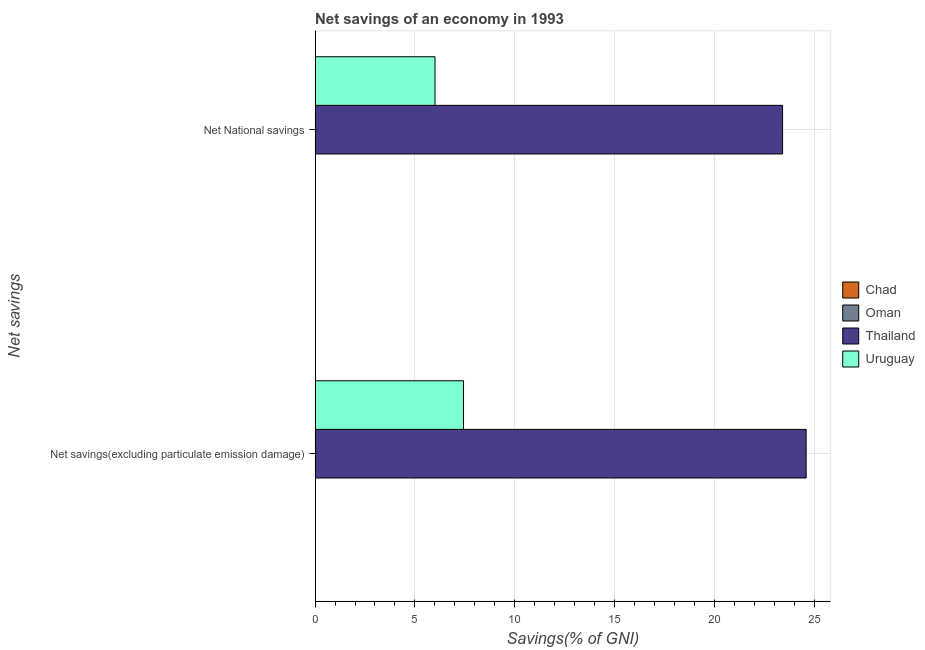How many bars are there on the 2nd tick from the bottom?
Your response must be concise. 2. What is the label of the 1st group of bars from the top?
Provide a short and direct response. Net National savings. What is the net savings(excluding particulate emission damage) in Oman?
Offer a very short reply. 0. Across all countries, what is the maximum net national savings?
Your answer should be compact. 23.42. In which country was the net national savings maximum?
Your response must be concise. Thailand. What is the total net savings(excluding particulate emission damage) in the graph?
Your response must be concise. 32.03. What is the difference between the net national savings in Thailand and that in Uruguay?
Provide a succinct answer. 17.41. What is the difference between the net national savings in Oman and the net savings(excluding particulate emission damage) in Thailand?
Offer a terse response. -24.6. What is the average net national savings per country?
Give a very brief answer. 7.36. What is the difference between the net savings(excluding particulate emission damage) and net national savings in Uruguay?
Ensure brevity in your answer.  1.43. In how many countries, is the net national savings greater than 13 %?
Ensure brevity in your answer.  1. What is the ratio of the net national savings in Thailand to that in Uruguay?
Ensure brevity in your answer.  3.9. Are all the bars in the graph horizontal?
Provide a short and direct response. Yes. What is the difference between two consecutive major ticks on the X-axis?
Your response must be concise. 5. Are the values on the major ticks of X-axis written in scientific E-notation?
Your answer should be very brief. No. Where does the legend appear in the graph?
Your answer should be compact. Center right. How many legend labels are there?
Your answer should be very brief. 4. What is the title of the graph?
Keep it short and to the point. Net savings of an economy in 1993. What is the label or title of the X-axis?
Offer a very short reply. Savings(% of GNI). What is the label or title of the Y-axis?
Ensure brevity in your answer.  Net savings. What is the Savings(% of GNI) in Thailand in Net savings(excluding particulate emission damage)?
Offer a very short reply. 24.6. What is the Savings(% of GNI) in Uruguay in Net savings(excluding particulate emission damage)?
Provide a succinct answer. 7.43. What is the Savings(% of GNI) of Chad in Net National savings?
Give a very brief answer. 0. What is the Savings(% of GNI) in Oman in Net National savings?
Keep it short and to the point. 0. What is the Savings(% of GNI) in Thailand in Net National savings?
Provide a short and direct response. 23.42. What is the Savings(% of GNI) in Uruguay in Net National savings?
Your answer should be very brief. 6.01. Across all Net savings, what is the maximum Savings(% of GNI) of Thailand?
Provide a short and direct response. 24.6. Across all Net savings, what is the maximum Savings(% of GNI) of Uruguay?
Your response must be concise. 7.43. Across all Net savings, what is the minimum Savings(% of GNI) of Thailand?
Your response must be concise. 23.42. Across all Net savings, what is the minimum Savings(% of GNI) of Uruguay?
Offer a terse response. 6.01. What is the total Savings(% of GNI) of Thailand in the graph?
Give a very brief answer. 48.02. What is the total Savings(% of GNI) of Uruguay in the graph?
Provide a short and direct response. 13.44. What is the difference between the Savings(% of GNI) in Thailand in Net savings(excluding particulate emission damage) and that in Net National savings?
Your response must be concise. 1.18. What is the difference between the Savings(% of GNI) in Uruguay in Net savings(excluding particulate emission damage) and that in Net National savings?
Provide a succinct answer. 1.43. What is the difference between the Savings(% of GNI) in Thailand in Net savings(excluding particulate emission damage) and the Savings(% of GNI) in Uruguay in Net National savings?
Provide a short and direct response. 18.59. What is the average Savings(% of GNI) of Chad per Net savings?
Your response must be concise. 0. What is the average Savings(% of GNI) in Oman per Net savings?
Provide a short and direct response. 0. What is the average Savings(% of GNI) of Thailand per Net savings?
Offer a terse response. 24.01. What is the average Savings(% of GNI) in Uruguay per Net savings?
Ensure brevity in your answer.  6.72. What is the difference between the Savings(% of GNI) in Thailand and Savings(% of GNI) in Uruguay in Net savings(excluding particulate emission damage)?
Your answer should be very brief. 17.16. What is the difference between the Savings(% of GNI) in Thailand and Savings(% of GNI) in Uruguay in Net National savings?
Your answer should be very brief. 17.41. What is the ratio of the Savings(% of GNI) in Thailand in Net savings(excluding particulate emission damage) to that in Net National savings?
Provide a succinct answer. 1.05. What is the ratio of the Savings(% of GNI) of Uruguay in Net savings(excluding particulate emission damage) to that in Net National savings?
Give a very brief answer. 1.24. What is the difference between the highest and the second highest Savings(% of GNI) of Thailand?
Ensure brevity in your answer.  1.18. What is the difference between the highest and the second highest Savings(% of GNI) of Uruguay?
Ensure brevity in your answer.  1.43. What is the difference between the highest and the lowest Savings(% of GNI) in Thailand?
Make the answer very short. 1.18. What is the difference between the highest and the lowest Savings(% of GNI) in Uruguay?
Your answer should be very brief. 1.43. 